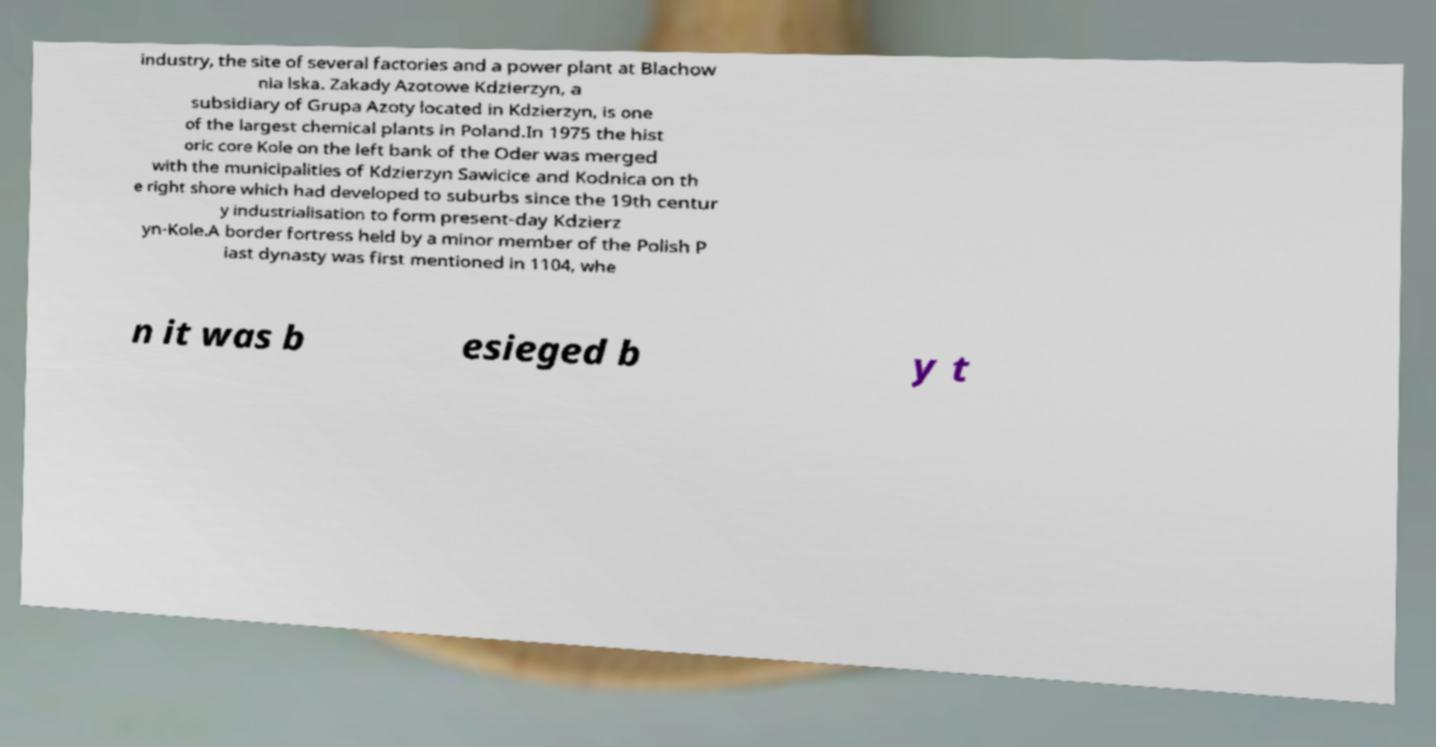Could you extract and type out the text from this image? industry, the site of several factories and a power plant at Blachow nia lska. Zakady Azotowe Kdzierzyn, a subsidiary of Grupa Azoty located in Kdzierzyn, is one of the largest chemical plants in Poland.In 1975 the hist oric core Kole on the left bank of the Oder was merged with the municipalities of Kdzierzyn Sawicice and Kodnica on th e right shore which had developed to suburbs since the 19th centur y industrialisation to form present-day Kdzierz yn-Kole.A border fortress held by a minor member of the Polish P iast dynasty was first mentioned in 1104, whe n it was b esieged b y t 